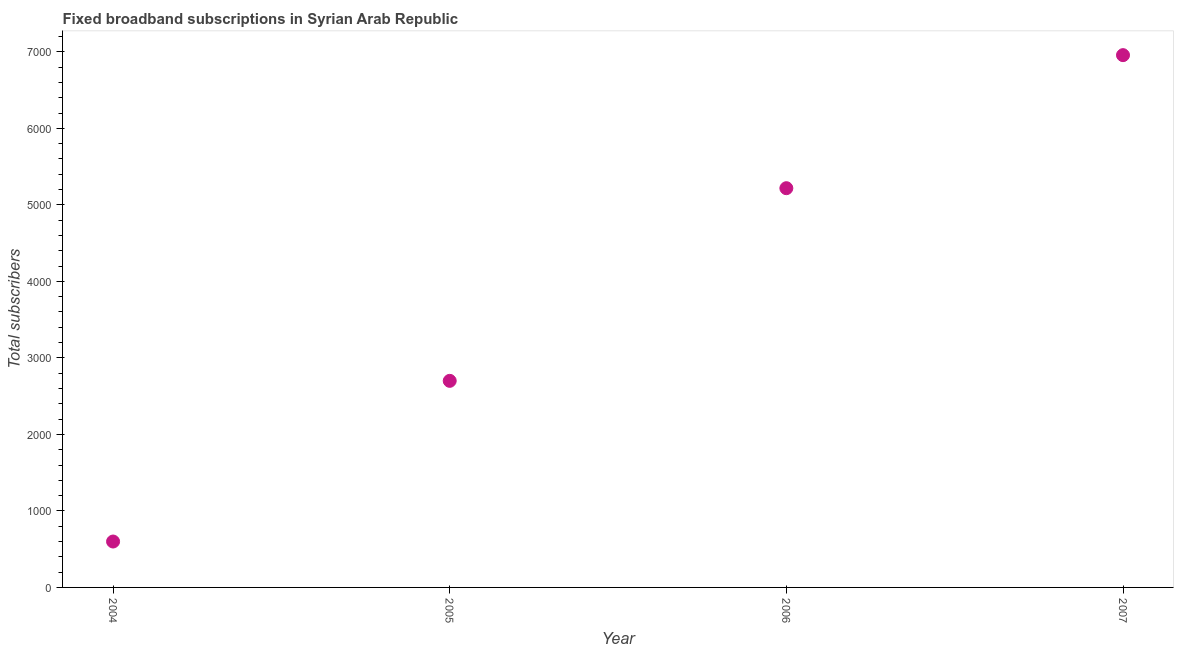What is the total number of fixed broadband subscriptions in 2007?
Your answer should be very brief. 6957. Across all years, what is the maximum total number of fixed broadband subscriptions?
Ensure brevity in your answer.  6957. Across all years, what is the minimum total number of fixed broadband subscriptions?
Provide a short and direct response. 600. What is the sum of the total number of fixed broadband subscriptions?
Make the answer very short. 1.55e+04. What is the difference between the total number of fixed broadband subscriptions in 2004 and 2006?
Give a very brief answer. -4618. What is the average total number of fixed broadband subscriptions per year?
Make the answer very short. 3868.75. What is the median total number of fixed broadband subscriptions?
Your answer should be compact. 3959. Do a majority of the years between 2007 and 2004 (inclusive) have total number of fixed broadband subscriptions greater than 5000 ?
Ensure brevity in your answer.  Yes. What is the ratio of the total number of fixed broadband subscriptions in 2004 to that in 2007?
Provide a short and direct response. 0.09. Is the total number of fixed broadband subscriptions in 2004 less than that in 2005?
Keep it short and to the point. Yes. Is the difference between the total number of fixed broadband subscriptions in 2004 and 2005 greater than the difference between any two years?
Keep it short and to the point. No. What is the difference between the highest and the second highest total number of fixed broadband subscriptions?
Make the answer very short. 1739. What is the difference between the highest and the lowest total number of fixed broadband subscriptions?
Offer a very short reply. 6357. What is the title of the graph?
Ensure brevity in your answer.  Fixed broadband subscriptions in Syrian Arab Republic. What is the label or title of the X-axis?
Offer a very short reply. Year. What is the label or title of the Y-axis?
Your answer should be very brief. Total subscribers. What is the Total subscribers in 2004?
Make the answer very short. 600. What is the Total subscribers in 2005?
Your response must be concise. 2700. What is the Total subscribers in 2006?
Make the answer very short. 5218. What is the Total subscribers in 2007?
Your response must be concise. 6957. What is the difference between the Total subscribers in 2004 and 2005?
Provide a succinct answer. -2100. What is the difference between the Total subscribers in 2004 and 2006?
Your answer should be very brief. -4618. What is the difference between the Total subscribers in 2004 and 2007?
Give a very brief answer. -6357. What is the difference between the Total subscribers in 2005 and 2006?
Your answer should be compact. -2518. What is the difference between the Total subscribers in 2005 and 2007?
Ensure brevity in your answer.  -4257. What is the difference between the Total subscribers in 2006 and 2007?
Keep it short and to the point. -1739. What is the ratio of the Total subscribers in 2004 to that in 2005?
Give a very brief answer. 0.22. What is the ratio of the Total subscribers in 2004 to that in 2006?
Offer a terse response. 0.12. What is the ratio of the Total subscribers in 2004 to that in 2007?
Ensure brevity in your answer.  0.09. What is the ratio of the Total subscribers in 2005 to that in 2006?
Offer a very short reply. 0.52. What is the ratio of the Total subscribers in 2005 to that in 2007?
Ensure brevity in your answer.  0.39. What is the ratio of the Total subscribers in 2006 to that in 2007?
Make the answer very short. 0.75. 